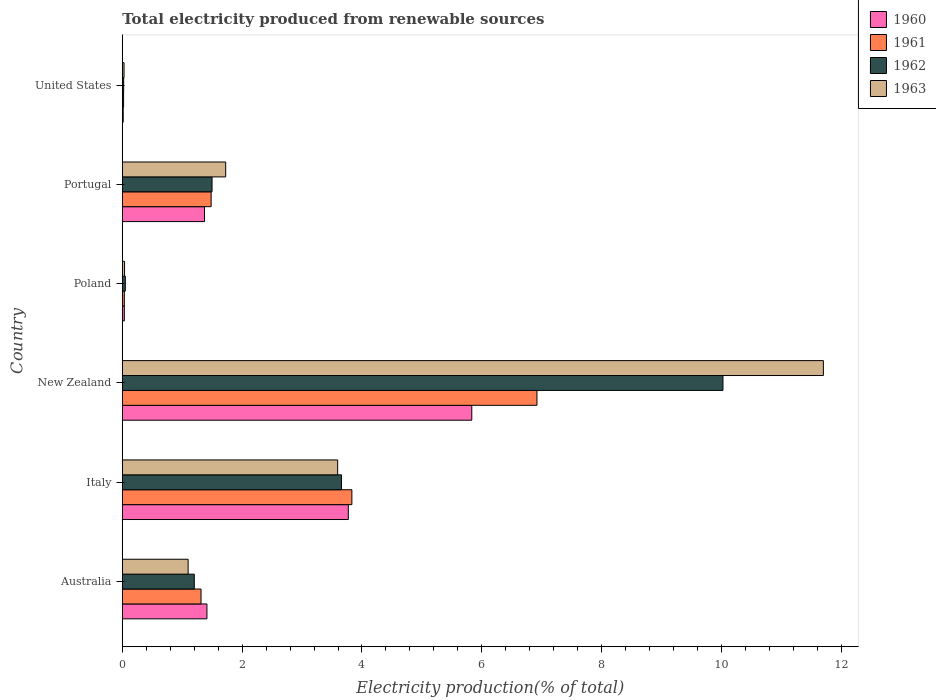What is the label of the 1st group of bars from the top?
Ensure brevity in your answer.  United States. In how many cases, is the number of bars for a given country not equal to the number of legend labels?
Offer a terse response. 0. What is the total electricity produced in 1961 in Portugal?
Your response must be concise. 1.48. Across all countries, what is the maximum total electricity produced in 1963?
Make the answer very short. 11.7. Across all countries, what is the minimum total electricity produced in 1960?
Give a very brief answer. 0.02. In which country was the total electricity produced in 1962 maximum?
Ensure brevity in your answer.  New Zealand. What is the total total electricity produced in 1962 in the graph?
Provide a succinct answer. 16.46. What is the difference between the total electricity produced in 1961 in Italy and that in United States?
Offer a terse response. 3.81. What is the difference between the total electricity produced in 1960 in Italy and the total electricity produced in 1961 in New Zealand?
Offer a very short reply. -3.15. What is the average total electricity produced in 1960 per country?
Ensure brevity in your answer.  2.07. What is the difference between the total electricity produced in 1963 and total electricity produced in 1962 in Portugal?
Keep it short and to the point. 0.23. What is the ratio of the total electricity produced in 1961 in Italy to that in New Zealand?
Make the answer very short. 0.55. Is the total electricity produced in 1961 in Australia less than that in Portugal?
Provide a short and direct response. Yes. What is the difference between the highest and the second highest total electricity produced in 1962?
Offer a very short reply. 6.37. What is the difference between the highest and the lowest total electricity produced in 1960?
Offer a terse response. 5.82. Is the sum of the total electricity produced in 1961 in Australia and Poland greater than the maximum total electricity produced in 1963 across all countries?
Your answer should be compact. No. Is it the case that in every country, the sum of the total electricity produced in 1961 and total electricity produced in 1962 is greater than the sum of total electricity produced in 1963 and total electricity produced in 1960?
Make the answer very short. No. What does the 4th bar from the top in Poland represents?
Your answer should be compact. 1960. Is it the case that in every country, the sum of the total electricity produced in 1960 and total electricity produced in 1962 is greater than the total electricity produced in 1961?
Offer a terse response. Yes. How many bars are there?
Offer a terse response. 24. How many countries are there in the graph?
Offer a very short reply. 6. What is the difference between two consecutive major ticks on the X-axis?
Offer a very short reply. 2. Are the values on the major ticks of X-axis written in scientific E-notation?
Your answer should be compact. No. Does the graph contain any zero values?
Provide a succinct answer. No. Where does the legend appear in the graph?
Your answer should be compact. Top right. How are the legend labels stacked?
Make the answer very short. Vertical. What is the title of the graph?
Ensure brevity in your answer.  Total electricity produced from renewable sources. What is the label or title of the X-axis?
Your answer should be compact. Electricity production(% of total). What is the Electricity production(% of total) in 1960 in Australia?
Keep it short and to the point. 1.41. What is the Electricity production(% of total) of 1961 in Australia?
Provide a succinct answer. 1.31. What is the Electricity production(% of total) in 1962 in Australia?
Ensure brevity in your answer.  1.2. What is the Electricity production(% of total) in 1963 in Australia?
Give a very brief answer. 1.1. What is the Electricity production(% of total) of 1960 in Italy?
Provide a succinct answer. 3.77. What is the Electricity production(% of total) of 1961 in Italy?
Give a very brief answer. 3.83. What is the Electricity production(% of total) in 1962 in Italy?
Keep it short and to the point. 3.66. What is the Electricity production(% of total) in 1963 in Italy?
Your response must be concise. 3.59. What is the Electricity production(% of total) of 1960 in New Zealand?
Your answer should be very brief. 5.83. What is the Electricity production(% of total) in 1961 in New Zealand?
Your answer should be compact. 6.92. What is the Electricity production(% of total) of 1962 in New Zealand?
Give a very brief answer. 10.02. What is the Electricity production(% of total) of 1963 in New Zealand?
Your answer should be compact. 11.7. What is the Electricity production(% of total) in 1960 in Poland?
Provide a short and direct response. 0.03. What is the Electricity production(% of total) of 1961 in Poland?
Provide a short and direct response. 0.03. What is the Electricity production(% of total) in 1962 in Poland?
Your answer should be very brief. 0.05. What is the Electricity production(% of total) in 1963 in Poland?
Offer a terse response. 0.04. What is the Electricity production(% of total) of 1960 in Portugal?
Your answer should be very brief. 1.37. What is the Electricity production(% of total) of 1961 in Portugal?
Your response must be concise. 1.48. What is the Electricity production(% of total) in 1962 in Portugal?
Give a very brief answer. 1.5. What is the Electricity production(% of total) in 1963 in Portugal?
Ensure brevity in your answer.  1.73. What is the Electricity production(% of total) in 1960 in United States?
Offer a very short reply. 0.02. What is the Electricity production(% of total) of 1961 in United States?
Offer a very short reply. 0.02. What is the Electricity production(% of total) in 1962 in United States?
Offer a very short reply. 0.02. What is the Electricity production(% of total) in 1963 in United States?
Ensure brevity in your answer.  0.03. Across all countries, what is the maximum Electricity production(% of total) in 1960?
Offer a very short reply. 5.83. Across all countries, what is the maximum Electricity production(% of total) in 1961?
Your response must be concise. 6.92. Across all countries, what is the maximum Electricity production(% of total) in 1962?
Provide a short and direct response. 10.02. Across all countries, what is the maximum Electricity production(% of total) of 1963?
Offer a terse response. 11.7. Across all countries, what is the minimum Electricity production(% of total) in 1960?
Offer a terse response. 0.02. Across all countries, what is the minimum Electricity production(% of total) in 1961?
Offer a terse response. 0.02. Across all countries, what is the minimum Electricity production(% of total) of 1962?
Keep it short and to the point. 0.02. Across all countries, what is the minimum Electricity production(% of total) of 1963?
Your answer should be compact. 0.03. What is the total Electricity production(% of total) in 1960 in the graph?
Ensure brevity in your answer.  12.44. What is the total Electricity production(% of total) of 1961 in the graph?
Offer a terse response. 13.6. What is the total Electricity production(% of total) in 1962 in the graph?
Provide a succinct answer. 16.46. What is the total Electricity production(% of total) in 1963 in the graph?
Keep it short and to the point. 18.19. What is the difference between the Electricity production(% of total) in 1960 in Australia and that in Italy?
Keep it short and to the point. -2.36. What is the difference between the Electricity production(% of total) in 1961 in Australia and that in Italy?
Your response must be concise. -2.52. What is the difference between the Electricity production(% of total) in 1962 in Australia and that in Italy?
Your answer should be very brief. -2.46. What is the difference between the Electricity production(% of total) of 1963 in Australia and that in Italy?
Offer a very short reply. -2.5. What is the difference between the Electricity production(% of total) of 1960 in Australia and that in New Zealand?
Your answer should be compact. -4.42. What is the difference between the Electricity production(% of total) in 1961 in Australia and that in New Zealand?
Your response must be concise. -5.61. What is the difference between the Electricity production(% of total) of 1962 in Australia and that in New Zealand?
Your answer should be very brief. -8.82. What is the difference between the Electricity production(% of total) in 1963 in Australia and that in New Zealand?
Provide a succinct answer. -10.6. What is the difference between the Electricity production(% of total) of 1960 in Australia and that in Poland?
Offer a terse response. 1.38. What is the difference between the Electricity production(% of total) of 1961 in Australia and that in Poland?
Ensure brevity in your answer.  1.28. What is the difference between the Electricity production(% of total) of 1962 in Australia and that in Poland?
Offer a very short reply. 1.15. What is the difference between the Electricity production(% of total) of 1963 in Australia and that in Poland?
Offer a very short reply. 1.06. What is the difference between the Electricity production(% of total) in 1960 in Australia and that in Portugal?
Offer a very short reply. 0.04. What is the difference between the Electricity production(% of total) of 1961 in Australia and that in Portugal?
Provide a short and direct response. -0.17. What is the difference between the Electricity production(% of total) of 1962 in Australia and that in Portugal?
Provide a succinct answer. -0.3. What is the difference between the Electricity production(% of total) in 1963 in Australia and that in Portugal?
Provide a short and direct response. -0.63. What is the difference between the Electricity production(% of total) in 1960 in Australia and that in United States?
Give a very brief answer. 1.4. What is the difference between the Electricity production(% of total) of 1961 in Australia and that in United States?
Your response must be concise. 1.29. What is the difference between the Electricity production(% of total) in 1962 in Australia and that in United States?
Give a very brief answer. 1.18. What is the difference between the Electricity production(% of total) of 1963 in Australia and that in United States?
Provide a short and direct response. 1.07. What is the difference between the Electricity production(% of total) of 1960 in Italy and that in New Zealand?
Make the answer very short. -2.06. What is the difference between the Electricity production(% of total) of 1961 in Italy and that in New Zealand?
Your answer should be compact. -3.09. What is the difference between the Electricity production(% of total) of 1962 in Italy and that in New Zealand?
Give a very brief answer. -6.37. What is the difference between the Electricity production(% of total) of 1963 in Italy and that in New Zealand?
Give a very brief answer. -8.11. What is the difference between the Electricity production(% of total) of 1960 in Italy and that in Poland?
Your answer should be very brief. 3.74. What is the difference between the Electricity production(% of total) in 1961 in Italy and that in Poland?
Keep it short and to the point. 3.8. What is the difference between the Electricity production(% of total) of 1962 in Italy and that in Poland?
Provide a short and direct response. 3.61. What is the difference between the Electricity production(% of total) of 1963 in Italy and that in Poland?
Offer a terse response. 3.56. What is the difference between the Electricity production(% of total) of 1960 in Italy and that in Portugal?
Keep it short and to the point. 2.4. What is the difference between the Electricity production(% of total) of 1961 in Italy and that in Portugal?
Give a very brief answer. 2.35. What is the difference between the Electricity production(% of total) in 1962 in Italy and that in Portugal?
Your answer should be very brief. 2.16. What is the difference between the Electricity production(% of total) in 1963 in Italy and that in Portugal?
Offer a very short reply. 1.87. What is the difference between the Electricity production(% of total) of 1960 in Italy and that in United States?
Give a very brief answer. 3.76. What is the difference between the Electricity production(% of total) of 1961 in Italy and that in United States?
Your answer should be very brief. 3.81. What is the difference between the Electricity production(% of total) in 1962 in Italy and that in United States?
Provide a short and direct response. 3.64. What is the difference between the Electricity production(% of total) of 1963 in Italy and that in United States?
Provide a succinct answer. 3.56. What is the difference between the Electricity production(% of total) in 1960 in New Zealand and that in Poland?
Keep it short and to the point. 5.8. What is the difference between the Electricity production(% of total) of 1961 in New Zealand and that in Poland?
Keep it short and to the point. 6.89. What is the difference between the Electricity production(% of total) in 1962 in New Zealand and that in Poland?
Your answer should be compact. 9.97. What is the difference between the Electricity production(% of total) in 1963 in New Zealand and that in Poland?
Offer a terse response. 11.66. What is the difference between the Electricity production(% of total) in 1960 in New Zealand and that in Portugal?
Give a very brief answer. 4.46. What is the difference between the Electricity production(% of total) of 1961 in New Zealand and that in Portugal?
Provide a succinct answer. 5.44. What is the difference between the Electricity production(% of total) of 1962 in New Zealand and that in Portugal?
Ensure brevity in your answer.  8.53. What is the difference between the Electricity production(% of total) of 1963 in New Zealand and that in Portugal?
Ensure brevity in your answer.  9.97. What is the difference between the Electricity production(% of total) in 1960 in New Zealand and that in United States?
Keep it short and to the point. 5.82. What is the difference between the Electricity production(% of total) in 1961 in New Zealand and that in United States?
Make the answer very short. 6.9. What is the difference between the Electricity production(% of total) of 1962 in New Zealand and that in United States?
Provide a succinct answer. 10. What is the difference between the Electricity production(% of total) of 1963 in New Zealand and that in United States?
Your response must be concise. 11.67. What is the difference between the Electricity production(% of total) of 1960 in Poland and that in Portugal?
Your answer should be very brief. -1.34. What is the difference between the Electricity production(% of total) of 1961 in Poland and that in Portugal?
Your response must be concise. -1.45. What is the difference between the Electricity production(% of total) in 1962 in Poland and that in Portugal?
Your response must be concise. -1.45. What is the difference between the Electricity production(% of total) of 1963 in Poland and that in Portugal?
Your response must be concise. -1.69. What is the difference between the Electricity production(% of total) in 1960 in Poland and that in United States?
Provide a short and direct response. 0.02. What is the difference between the Electricity production(% of total) of 1961 in Poland and that in United States?
Your answer should be very brief. 0.01. What is the difference between the Electricity production(% of total) of 1962 in Poland and that in United States?
Make the answer very short. 0.03. What is the difference between the Electricity production(% of total) of 1963 in Poland and that in United States?
Provide a succinct answer. 0.01. What is the difference between the Electricity production(% of total) in 1960 in Portugal and that in United States?
Keep it short and to the point. 1.36. What is the difference between the Electricity production(% of total) in 1961 in Portugal and that in United States?
Make the answer very short. 1.46. What is the difference between the Electricity production(% of total) of 1962 in Portugal and that in United States?
Provide a short and direct response. 1.48. What is the difference between the Electricity production(% of total) in 1963 in Portugal and that in United States?
Your answer should be compact. 1.7. What is the difference between the Electricity production(% of total) of 1960 in Australia and the Electricity production(% of total) of 1961 in Italy?
Your answer should be compact. -2.42. What is the difference between the Electricity production(% of total) in 1960 in Australia and the Electricity production(% of total) in 1962 in Italy?
Provide a short and direct response. -2.25. What is the difference between the Electricity production(% of total) in 1960 in Australia and the Electricity production(% of total) in 1963 in Italy?
Offer a very short reply. -2.18. What is the difference between the Electricity production(% of total) in 1961 in Australia and the Electricity production(% of total) in 1962 in Italy?
Provide a succinct answer. -2.34. What is the difference between the Electricity production(% of total) in 1961 in Australia and the Electricity production(% of total) in 1963 in Italy?
Offer a terse response. -2.28. What is the difference between the Electricity production(% of total) in 1962 in Australia and the Electricity production(% of total) in 1963 in Italy?
Keep it short and to the point. -2.39. What is the difference between the Electricity production(% of total) of 1960 in Australia and the Electricity production(% of total) of 1961 in New Zealand?
Ensure brevity in your answer.  -5.51. What is the difference between the Electricity production(% of total) of 1960 in Australia and the Electricity production(% of total) of 1962 in New Zealand?
Provide a short and direct response. -8.61. What is the difference between the Electricity production(% of total) in 1960 in Australia and the Electricity production(% of total) in 1963 in New Zealand?
Your answer should be very brief. -10.29. What is the difference between the Electricity production(% of total) of 1961 in Australia and the Electricity production(% of total) of 1962 in New Zealand?
Provide a succinct answer. -8.71. What is the difference between the Electricity production(% of total) in 1961 in Australia and the Electricity production(% of total) in 1963 in New Zealand?
Offer a very short reply. -10.39. What is the difference between the Electricity production(% of total) in 1962 in Australia and the Electricity production(% of total) in 1963 in New Zealand?
Your answer should be compact. -10.5. What is the difference between the Electricity production(% of total) in 1960 in Australia and the Electricity production(% of total) in 1961 in Poland?
Offer a very short reply. 1.38. What is the difference between the Electricity production(% of total) in 1960 in Australia and the Electricity production(% of total) in 1962 in Poland?
Give a very brief answer. 1.36. What is the difference between the Electricity production(% of total) of 1960 in Australia and the Electricity production(% of total) of 1963 in Poland?
Your answer should be compact. 1.37. What is the difference between the Electricity production(% of total) in 1961 in Australia and the Electricity production(% of total) in 1962 in Poland?
Ensure brevity in your answer.  1.26. What is the difference between the Electricity production(% of total) in 1961 in Australia and the Electricity production(% of total) in 1963 in Poland?
Offer a very short reply. 1.28. What is the difference between the Electricity production(% of total) of 1962 in Australia and the Electricity production(% of total) of 1963 in Poland?
Ensure brevity in your answer.  1.16. What is the difference between the Electricity production(% of total) in 1960 in Australia and the Electricity production(% of total) in 1961 in Portugal?
Your response must be concise. -0.07. What is the difference between the Electricity production(% of total) of 1960 in Australia and the Electricity production(% of total) of 1962 in Portugal?
Offer a terse response. -0.09. What is the difference between the Electricity production(% of total) of 1960 in Australia and the Electricity production(% of total) of 1963 in Portugal?
Provide a succinct answer. -0.31. What is the difference between the Electricity production(% of total) of 1961 in Australia and the Electricity production(% of total) of 1962 in Portugal?
Provide a succinct answer. -0.18. What is the difference between the Electricity production(% of total) in 1961 in Australia and the Electricity production(% of total) in 1963 in Portugal?
Ensure brevity in your answer.  -0.41. What is the difference between the Electricity production(% of total) in 1962 in Australia and the Electricity production(% of total) in 1963 in Portugal?
Keep it short and to the point. -0.52. What is the difference between the Electricity production(% of total) in 1960 in Australia and the Electricity production(% of total) in 1961 in United States?
Give a very brief answer. 1.39. What is the difference between the Electricity production(% of total) of 1960 in Australia and the Electricity production(% of total) of 1962 in United States?
Ensure brevity in your answer.  1.39. What is the difference between the Electricity production(% of total) of 1960 in Australia and the Electricity production(% of total) of 1963 in United States?
Your response must be concise. 1.38. What is the difference between the Electricity production(% of total) in 1961 in Australia and the Electricity production(% of total) in 1962 in United States?
Give a very brief answer. 1.29. What is the difference between the Electricity production(% of total) of 1961 in Australia and the Electricity production(% of total) of 1963 in United States?
Give a very brief answer. 1.28. What is the difference between the Electricity production(% of total) in 1962 in Australia and the Electricity production(% of total) in 1963 in United States?
Your response must be concise. 1.17. What is the difference between the Electricity production(% of total) in 1960 in Italy and the Electricity production(% of total) in 1961 in New Zealand?
Offer a terse response. -3.15. What is the difference between the Electricity production(% of total) of 1960 in Italy and the Electricity production(% of total) of 1962 in New Zealand?
Your answer should be very brief. -6.25. What is the difference between the Electricity production(% of total) in 1960 in Italy and the Electricity production(% of total) in 1963 in New Zealand?
Your response must be concise. -7.93. What is the difference between the Electricity production(% of total) in 1961 in Italy and the Electricity production(% of total) in 1962 in New Zealand?
Give a very brief answer. -6.19. What is the difference between the Electricity production(% of total) in 1961 in Italy and the Electricity production(% of total) in 1963 in New Zealand?
Your answer should be very brief. -7.87. What is the difference between the Electricity production(% of total) in 1962 in Italy and the Electricity production(% of total) in 1963 in New Zealand?
Make the answer very short. -8.04. What is the difference between the Electricity production(% of total) of 1960 in Italy and the Electricity production(% of total) of 1961 in Poland?
Keep it short and to the point. 3.74. What is the difference between the Electricity production(% of total) in 1960 in Italy and the Electricity production(% of total) in 1962 in Poland?
Your answer should be compact. 3.72. What is the difference between the Electricity production(% of total) in 1960 in Italy and the Electricity production(% of total) in 1963 in Poland?
Ensure brevity in your answer.  3.73. What is the difference between the Electricity production(% of total) in 1961 in Italy and the Electricity production(% of total) in 1962 in Poland?
Make the answer very short. 3.78. What is the difference between the Electricity production(% of total) of 1961 in Italy and the Electricity production(% of total) of 1963 in Poland?
Offer a terse response. 3.79. What is the difference between the Electricity production(% of total) in 1962 in Italy and the Electricity production(% of total) in 1963 in Poland?
Your answer should be compact. 3.62. What is the difference between the Electricity production(% of total) in 1960 in Italy and the Electricity production(% of total) in 1961 in Portugal?
Give a very brief answer. 2.29. What is the difference between the Electricity production(% of total) in 1960 in Italy and the Electricity production(% of total) in 1962 in Portugal?
Your answer should be compact. 2.27. What is the difference between the Electricity production(% of total) of 1960 in Italy and the Electricity production(% of total) of 1963 in Portugal?
Ensure brevity in your answer.  2.05. What is the difference between the Electricity production(% of total) of 1961 in Italy and the Electricity production(% of total) of 1962 in Portugal?
Provide a short and direct response. 2.33. What is the difference between the Electricity production(% of total) of 1961 in Italy and the Electricity production(% of total) of 1963 in Portugal?
Your answer should be very brief. 2.11. What is the difference between the Electricity production(% of total) in 1962 in Italy and the Electricity production(% of total) in 1963 in Portugal?
Provide a succinct answer. 1.93. What is the difference between the Electricity production(% of total) in 1960 in Italy and the Electricity production(% of total) in 1961 in United States?
Your answer should be compact. 3.75. What is the difference between the Electricity production(% of total) of 1960 in Italy and the Electricity production(% of total) of 1962 in United States?
Provide a short and direct response. 3.75. What is the difference between the Electricity production(% of total) in 1960 in Italy and the Electricity production(% of total) in 1963 in United States?
Provide a succinct answer. 3.74. What is the difference between the Electricity production(% of total) in 1961 in Italy and the Electricity production(% of total) in 1962 in United States?
Your answer should be very brief. 3.81. What is the difference between the Electricity production(% of total) in 1961 in Italy and the Electricity production(% of total) in 1963 in United States?
Offer a terse response. 3.8. What is the difference between the Electricity production(% of total) of 1962 in Italy and the Electricity production(% of total) of 1963 in United States?
Your answer should be compact. 3.63. What is the difference between the Electricity production(% of total) of 1960 in New Zealand and the Electricity production(% of total) of 1961 in Poland?
Ensure brevity in your answer.  5.8. What is the difference between the Electricity production(% of total) of 1960 in New Zealand and the Electricity production(% of total) of 1962 in Poland?
Provide a short and direct response. 5.78. What is the difference between the Electricity production(% of total) in 1960 in New Zealand and the Electricity production(% of total) in 1963 in Poland?
Give a very brief answer. 5.79. What is the difference between the Electricity production(% of total) of 1961 in New Zealand and the Electricity production(% of total) of 1962 in Poland?
Keep it short and to the point. 6.87. What is the difference between the Electricity production(% of total) in 1961 in New Zealand and the Electricity production(% of total) in 1963 in Poland?
Keep it short and to the point. 6.88. What is the difference between the Electricity production(% of total) in 1962 in New Zealand and the Electricity production(% of total) in 1963 in Poland?
Give a very brief answer. 9.99. What is the difference between the Electricity production(% of total) of 1960 in New Zealand and the Electricity production(% of total) of 1961 in Portugal?
Keep it short and to the point. 4.35. What is the difference between the Electricity production(% of total) in 1960 in New Zealand and the Electricity production(% of total) in 1962 in Portugal?
Your answer should be very brief. 4.33. What is the difference between the Electricity production(% of total) of 1960 in New Zealand and the Electricity production(% of total) of 1963 in Portugal?
Make the answer very short. 4.11. What is the difference between the Electricity production(% of total) in 1961 in New Zealand and the Electricity production(% of total) in 1962 in Portugal?
Make the answer very short. 5.42. What is the difference between the Electricity production(% of total) of 1961 in New Zealand and the Electricity production(% of total) of 1963 in Portugal?
Your response must be concise. 5.19. What is the difference between the Electricity production(% of total) in 1962 in New Zealand and the Electricity production(% of total) in 1963 in Portugal?
Ensure brevity in your answer.  8.3. What is the difference between the Electricity production(% of total) of 1960 in New Zealand and the Electricity production(% of total) of 1961 in United States?
Make the answer very short. 5.81. What is the difference between the Electricity production(% of total) in 1960 in New Zealand and the Electricity production(% of total) in 1962 in United States?
Your response must be concise. 5.81. What is the difference between the Electricity production(% of total) of 1960 in New Zealand and the Electricity production(% of total) of 1963 in United States?
Keep it short and to the point. 5.8. What is the difference between the Electricity production(% of total) in 1961 in New Zealand and the Electricity production(% of total) in 1962 in United States?
Your answer should be very brief. 6.9. What is the difference between the Electricity production(% of total) in 1961 in New Zealand and the Electricity production(% of total) in 1963 in United States?
Ensure brevity in your answer.  6.89. What is the difference between the Electricity production(% of total) of 1962 in New Zealand and the Electricity production(% of total) of 1963 in United States?
Your response must be concise. 10. What is the difference between the Electricity production(% of total) in 1960 in Poland and the Electricity production(% of total) in 1961 in Portugal?
Provide a short and direct response. -1.45. What is the difference between the Electricity production(% of total) of 1960 in Poland and the Electricity production(% of total) of 1962 in Portugal?
Your response must be concise. -1.46. What is the difference between the Electricity production(% of total) of 1960 in Poland and the Electricity production(% of total) of 1963 in Portugal?
Your answer should be very brief. -1.69. What is the difference between the Electricity production(% of total) of 1961 in Poland and the Electricity production(% of total) of 1962 in Portugal?
Offer a terse response. -1.46. What is the difference between the Electricity production(% of total) of 1961 in Poland and the Electricity production(% of total) of 1963 in Portugal?
Your response must be concise. -1.69. What is the difference between the Electricity production(% of total) of 1962 in Poland and the Electricity production(% of total) of 1963 in Portugal?
Offer a very short reply. -1.67. What is the difference between the Electricity production(% of total) of 1960 in Poland and the Electricity production(% of total) of 1961 in United States?
Provide a succinct answer. 0.01. What is the difference between the Electricity production(% of total) in 1960 in Poland and the Electricity production(% of total) in 1962 in United States?
Ensure brevity in your answer.  0.01. What is the difference between the Electricity production(% of total) in 1960 in Poland and the Electricity production(% of total) in 1963 in United States?
Your response must be concise. 0. What is the difference between the Electricity production(% of total) in 1961 in Poland and the Electricity production(% of total) in 1962 in United States?
Provide a succinct answer. 0.01. What is the difference between the Electricity production(% of total) of 1961 in Poland and the Electricity production(% of total) of 1963 in United States?
Provide a succinct answer. 0. What is the difference between the Electricity production(% of total) of 1962 in Poland and the Electricity production(% of total) of 1963 in United States?
Provide a succinct answer. 0.02. What is the difference between the Electricity production(% of total) of 1960 in Portugal and the Electricity production(% of total) of 1961 in United States?
Give a very brief answer. 1.35. What is the difference between the Electricity production(% of total) in 1960 in Portugal and the Electricity production(% of total) in 1962 in United States?
Offer a very short reply. 1.35. What is the difference between the Electricity production(% of total) in 1960 in Portugal and the Electricity production(% of total) in 1963 in United States?
Offer a very short reply. 1.34. What is the difference between the Electricity production(% of total) of 1961 in Portugal and the Electricity production(% of total) of 1962 in United States?
Give a very brief answer. 1.46. What is the difference between the Electricity production(% of total) in 1961 in Portugal and the Electricity production(% of total) in 1963 in United States?
Offer a terse response. 1.45. What is the difference between the Electricity production(% of total) of 1962 in Portugal and the Electricity production(% of total) of 1963 in United States?
Offer a terse response. 1.47. What is the average Electricity production(% of total) in 1960 per country?
Your answer should be very brief. 2.07. What is the average Electricity production(% of total) in 1961 per country?
Give a very brief answer. 2.27. What is the average Electricity production(% of total) in 1962 per country?
Ensure brevity in your answer.  2.74. What is the average Electricity production(% of total) in 1963 per country?
Provide a short and direct response. 3.03. What is the difference between the Electricity production(% of total) in 1960 and Electricity production(% of total) in 1961 in Australia?
Ensure brevity in your answer.  0.1. What is the difference between the Electricity production(% of total) in 1960 and Electricity production(% of total) in 1962 in Australia?
Your answer should be very brief. 0.21. What is the difference between the Electricity production(% of total) in 1960 and Electricity production(% of total) in 1963 in Australia?
Give a very brief answer. 0.31. What is the difference between the Electricity production(% of total) of 1961 and Electricity production(% of total) of 1962 in Australia?
Provide a short and direct response. 0.11. What is the difference between the Electricity production(% of total) of 1961 and Electricity production(% of total) of 1963 in Australia?
Give a very brief answer. 0.21. What is the difference between the Electricity production(% of total) in 1962 and Electricity production(% of total) in 1963 in Australia?
Give a very brief answer. 0.1. What is the difference between the Electricity production(% of total) in 1960 and Electricity production(% of total) in 1961 in Italy?
Offer a very short reply. -0.06. What is the difference between the Electricity production(% of total) of 1960 and Electricity production(% of total) of 1962 in Italy?
Your response must be concise. 0.11. What is the difference between the Electricity production(% of total) of 1960 and Electricity production(% of total) of 1963 in Italy?
Offer a very short reply. 0.18. What is the difference between the Electricity production(% of total) in 1961 and Electricity production(% of total) in 1962 in Italy?
Your response must be concise. 0.17. What is the difference between the Electricity production(% of total) of 1961 and Electricity production(% of total) of 1963 in Italy?
Offer a terse response. 0.24. What is the difference between the Electricity production(% of total) in 1962 and Electricity production(% of total) in 1963 in Italy?
Make the answer very short. 0.06. What is the difference between the Electricity production(% of total) in 1960 and Electricity production(% of total) in 1961 in New Zealand?
Keep it short and to the point. -1.09. What is the difference between the Electricity production(% of total) of 1960 and Electricity production(% of total) of 1962 in New Zealand?
Give a very brief answer. -4.19. What is the difference between the Electricity production(% of total) of 1960 and Electricity production(% of total) of 1963 in New Zealand?
Your answer should be very brief. -5.87. What is the difference between the Electricity production(% of total) of 1961 and Electricity production(% of total) of 1962 in New Zealand?
Ensure brevity in your answer.  -3.1. What is the difference between the Electricity production(% of total) in 1961 and Electricity production(% of total) in 1963 in New Zealand?
Offer a terse response. -4.78. What is the difference between the Electricity production(% of total) of 1962 and Electricity production(% of total) of 1963 in New Zealand?
Provide a short and direct response. -1.68. What is the difference between the Electricity production(% of total) of 1960 and Electricity production(% of total) of 1962 in Poland?
Ensure brevity in your answer.  -0.02. What is the difference between the Electricity production(% of total) in 1960 and Electricity production(% of total) in 1963 in Poland?
Provide a short and direct response. -0. What is the difference between the Electricity production(% of total) in 1961 and Electricity production(% of total) in 1962 in Poland?
Your answer should be very brief. -0.02. What is the difference between the Electricity production(% of total) in 1961 and Electricity production(% of total) in 1963 in Poland?
Provide a short and direct response. -0. What is the difference between the Electricity production(% of total) in 1962 and Electricity production(% of total) in 1963 in Poland?
Ensure brevity in your answer.  0.01. What is the difference between the Electricity production(% of total) in 1960 and Electricity production(% of total) in 1961 in Portugal?
Give a very brief answer. -0.11. What is the difference between the Electricity production(% of total) in 1960 and Electricity production(% of total) in 1962 in Portugal?
Keep it short and to the point. -0.13. What is the difference between the Electricity production(% of total) in 1960 and Electricity production(% of total) in 1963 in Portugal?
Provide a succinct answer. -0.35. What is the difference between the Electricity production(% of total) in 1961 and Electricity production(% of total) in 1962 in Portugal?
Offer a very short reply. -0.02. What is the difference between the Electricity production(% of total) in 1961 and Electricity production(% of total) in 1963 in Portugal?
Provide a short and direct response. -0.24. What is the difference between the Electricity production(% of total) in 1962 and Electricity production(% of total) in 1963 in Portugal?
Your response must be concise. -0.23. What is the difference between the Electricity production(% of total) in 1960 and Electricity production(% of total) in 1961 in United States?
Keep it short and to the point. -0.01. What is the difference between the Electricity production(% of total) of 1960 and Electricity production(% of total) of 1962 in United States?
Provide a short and direct response. -0.01. What is the difference between the Electricity production(% of total) of 1960 and Electricity production(% of total) of 1963 in United States?
Your answer should be very brief. -0.01. What is the difference between the Electricity production(% of total) in 1961 and Electricity production(% of total) in 1962 in United States?
Offer a very short reply. -0. What is the difference between the Electricity production(% of total) in 1961 and Electricity production(% of total) in 1963 in United States?
Offer a very short reply. -0.01. What is the difference between the Electricity production(% of total) of 1962 and Electricity production(% of total) of 1963 in United States?
Your answer should be very brief. -0.01. What is the ratio of the Electricity production(% of total) in 1960 in Australia to that in Italy?
Offer a very short reply. 0.37. What is the ratio of the Electricity production(% of total) of 1961 in Australia to that in Italy?
Provide a short and direct response. 0.34. What is the ratio of the Electricity production(% of total) of 1962 in Australia to that in Italy?
Provide a short and direct response. 0.33. What is the ratio of the Electricity production(% of total) of 1963 in Australia to that in Italy?
Keep it short and to the point. 0.31. What is the ratio of the Electricity production(% of total) in 1960 in Australia to that in New Zealand?
Keep it short and to the point. 0.24. What is the ratio of the Electricity production(% of total) of 1961 in Australia to that in New Zealand?
Your answer should be very brief. 0.19. What is the ratio of the Electricity production(% of total) of 1962 in Australia to that in New Zealand?
Make the answer very short. 0.12. What is the ratio of the Electricity production(% of total) in 1963 in Australia to that in New Zealand?
Keep it short and to the point. 0.09. What is the ratio of the Electricity production(% of total) of 1960 in Australia to that in Poland?
Your response must be concise. 41.37. What is the ratio of the Electricity production(% of total) in 1961 in Australia to that in Poland?
Offer a terse response. 38.51. What is the ratio of the Electricity production(% of total) of 1962 in Australia to that in Poland?
Your answer should be very brief. 23.61. What is the ratio of the Electricity production(% of total) in 1963 in Australia to that in Poland?
Offer a terse response. 29. What is the ratio of the Electricity production(% of total) of 1960 in Australia to that in Portugal?
Make the answer very short. 1.03. What is the ratio of the Electricity production(% of total) of 1961 in Australia to that in Portugal?
Your answer should be very brief. 0.89. What is the ratio of the Electricity production(% of total) in 1962 in Australia to that in Portugal?
Keep it short and to the point. 0.8. What is the ratio of the Electricity production(% of total) in 1963 in Australia to that in Portugal?
Keep it short and to the point. 0.64. What is the ratio of the Electricity production(% of total) of 1960 in Australia to that in United States?
Offer a terse response. 92.6. What is the ratio of the Electricity production(% of total) of 1961 in Australia to that in United States?
Your answer should be compact. 61. What is the ratio of the Electricity production(% of total) in 1962 in Australia to that in United States?
Offer a terse response. 52.74. What is the ratio of the Electricity production(% of total) in 1963 in Australia to that in United States?
Offer a terse response. 37.34. What is the ratio of the Electricity production(% of total) in 1960 in Italy to that in New Zealand?
Offer a very short reply. 0.65. What is the ratio of the Electricity production(% of total) in 1961 in Italy to that in New Zealand?
Ensure brevity in your answer.  0.55. What is the ratio of the Electricity production(% of total) of 1962 in Italy to that in New Zealand?
Provide a short and direct response. 0.36. What is the ratio of the Electricity production(% of total) of 1963 in Italy to that in New Zealand?
Your answer should be compact. 0.31. What is the ratio of the Electricity production(% of total) in 1960 in Italy to that in Poland?
Provide a succinct answer. 110.45. What is the ratio of the Electricity production(% of total) of 1961 in Italy to that in Poland?
Your response must be concise. 112.3. What is the ratio of the Electricity production(% of total) in 1962 in Italy to that in Poland?
Provide a short and direct response. 71.88. What is the ratio of the Electricity production(% of total) of 1963 in Italy to that in Poland?
Provide a succinct answer. 94.84. What is the ratio of the Electricity production(% of total) in 1960 in Italy to that in Portugal?
Your answer should be compact. 2.75. What is the ratio of the Electricity production(% of total) of 1961 in Italy to that in Portugal?
Your answer should be compact. 2.58. What is the ratio of the Electricity production(% of total) of 1962 in Italy to that in Portugal?
Provide a succinct answer. 2.44. What is the ratio of the Electricity production(% of total) of 1963 in Italy to that in Portugal?
Make the answer very short. 2.08. What is the ratio of the Electricity production(% of total) in 1960 in Italy to that in United States?
Offer a terse response. 247.25. What is the ratio of the Electricity production(% of total) in 1961 in Italy to that in United States?
Give a very brief answer. 177.87. What is the ratio of the Electricity production(% of total) in 1962 in Italy to that in United States?
Make the answer very short. 160.56. What is the ratio of the Electricity production(% of total) of 1963 in Italy to that in United States?
Offer a terse response. 122.12. What is the ratio of the Electricity production(% of total) in 1960 in New Zealand to that in Poland?
Ensure brevity in your answer.  170.79. What is the ratio of the Electricity production(% of total) of 1961 in New Zealand to that in Poland?
Provide a succinct answer. 202.83. What is the ratio of the Electricity production(% of total) of 1962 in New Zealand to that in Poland?
Ensure brevity in your answer.  196.95. What is the ratio of the Electricity production(% of total) of 1963 in New Zealand to that in Poland?
Make the answer very short. 308.73. What is the ratio of the Electricity production(% of total) of 1960 in New Zealand to that in Portugal?
Make the answer very short. 4.25. What is the ratio of the Electricity production(% of total) of 1961 in New Zealand to that in Portugal?
Make the answer very short. 4.67. What is the ratio of the Electricity production(% of total) in 1962 in New Zealand to that in Portugal?
Your answer should be compact. 6.69. What is the ratio of the Electricity production(% of total) in 1963 in New Zealand to that in Portugal?
Ensure brevity in your answer.  6.78. What is the ratio of the Electricity production(% of total) of 1960 in New Zealand to that in United States?
Your answer should be very brief. 382.31. What is the ratio of the Electricity production(% of total) of 1961 in New Zealand to that in United States?
Keep it short and to the point. 321.25. What is the ratio of the Electricity production(% of total) of 1962 in New Zealand to that in United States?
Your answer should be compact. 439.93. What is the ratio of the Electricity production(% of total) of 1963 in New Zealand to that in United States?
Ensure brevity in your answer.  397.5. What is the ratio of the Electricity production(% of total) in 1960 in Poland to that in Portugal?
Your answer should be compact. 0.02. What is the ratio of the Electricity production(% of total) in 1961 in Poland to that in Portugal?
Your answer should be very brief. 0.02. What is the ratio of the Electricity production(% of total) in 1962 in Poland to that in Portugal?
Your response must be concise. 0.03. What is the ratio of the Electricity production(% of total) in 1963 in Poland to that in Portugal?
Provide a succinct answer. 0.02. What is the ratio of the Electricity production(% of total) of 1960 in Poland to that in United States?
Give a very brief answer. 2.24. What is the ratio of the Electricity production(% of total) of 1961 in Poland to that in United States?
Offer a very short reply. 1.58. What is the ratio of the Electricity production(% of total) of 1962 in Poland to that in United States?
Give a very brief answer. 2.23. What is the ratio of the Electricity production(% of total) of 1963 in Poland to that in United States?
Make the answer very short. 1.29. What is the ratio of the Electricity production(% of total) of 1960 in Portugal to that in United States?
Make the answer very short. 89.96. What is the ratio of the Electricity production(% of total) in 1961 in Portugal to that in United States?
Make the answer very short. 68.83. What is the ratio of the Electricity production(% of total) of 1962 in Portugal to that in United States?
Keep it short and to the point. 65.74. What is the ratio of the Electricity production(% of total) of 1963 in Portugal to that in United States?
Your response must be concise. 58.63. What is the difference between the highest and the second highest Electricity production(% of total) in 1960?
Offer a very short reply. 2.06. What is the difference between the highest and the second highest Electricity production(% of total) in 1961?
Ensure brevity in your answer.  3.09. What is the difference between the highest and the second highest Electricity production(% of total) of 1962?
Your answer should be compact. 6.37. What is the difference between the highest and the second highest Electricity production(% of total) in 1963?
Provide a short and direct response. 8.11. What is the difference between the highest and the lowest Electricity production(% of total) of 1960?
Offer a terse response. 5.82. What is the difference between the highest and the lowest Electricity production(% of total) of 1961?
Keep it short and to the point. 6.9. What is the difference between the highest and the lowest Electricity production(% of total) in 1962?
Your answer should be compact. 10. What is the difference between the highest and the lowest Electricity production(% of total) in 1963?
Give a very brief answer. 11.67. 